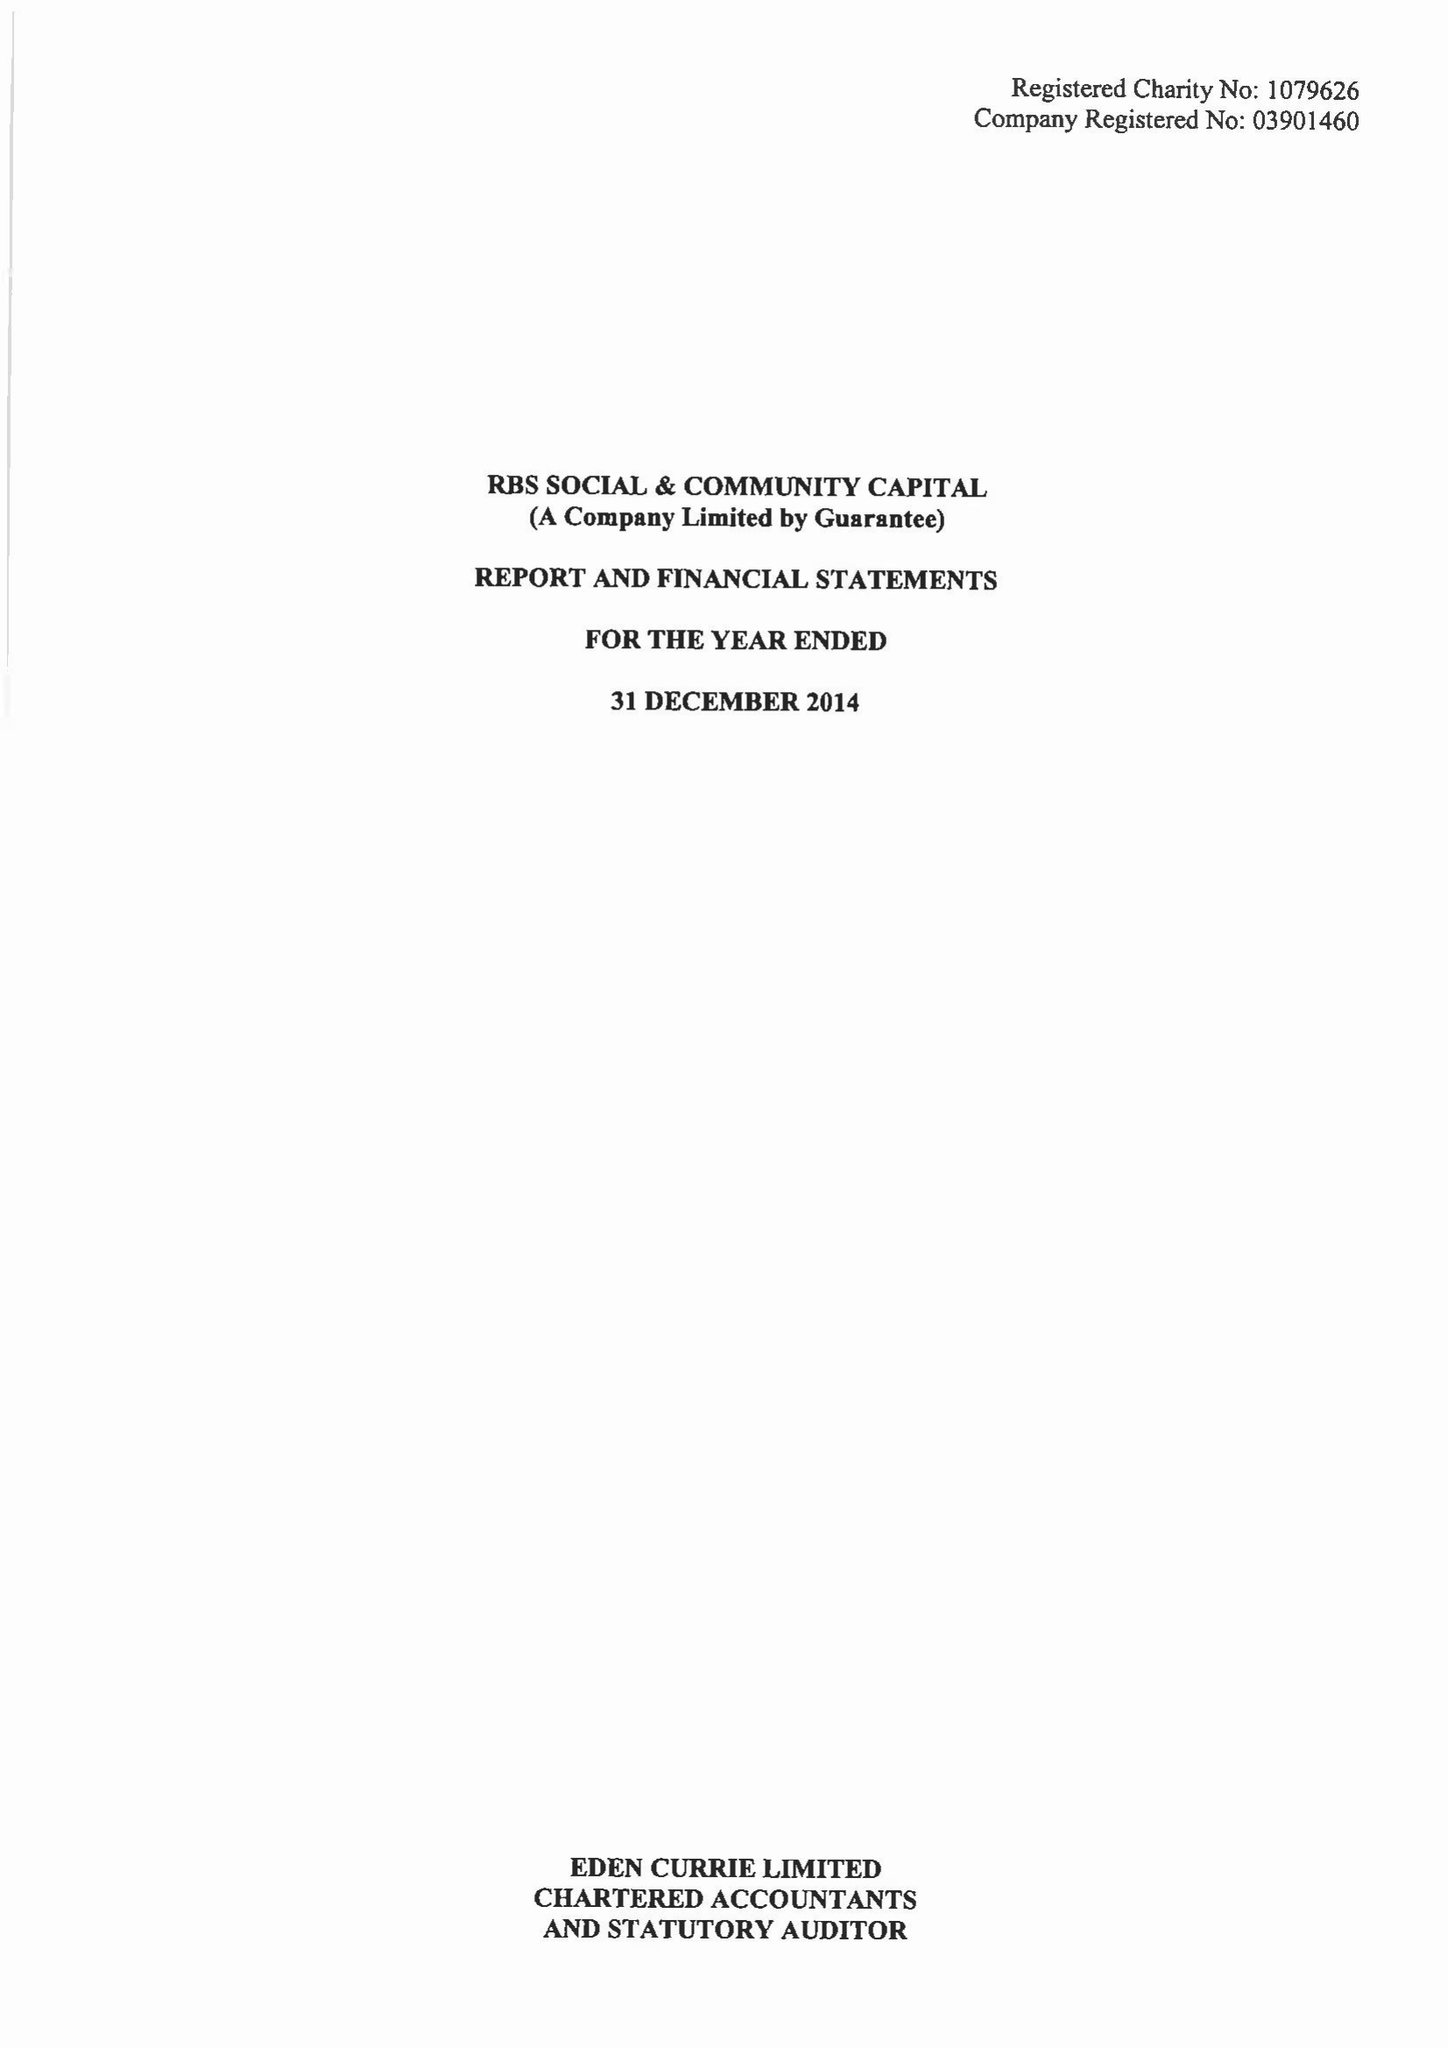What is the value for the income_annually_in_british_pounds?
Answer the question using a single word or phrase. 10284474.00 